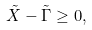<formula> <loc_0><loc_0><loc_500><loc_500>\tilde { X } - \tilde { \Gamma } \geq 0 ,</formula> 